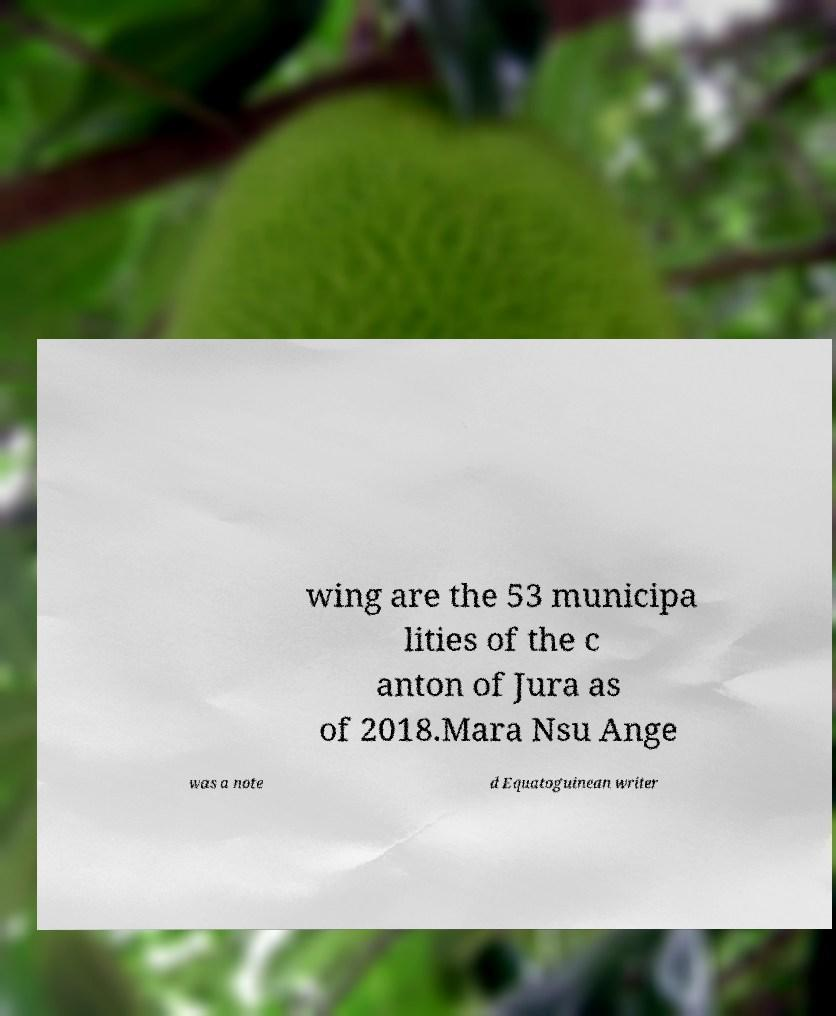I need the written content from this picture converted into text. Can you do that? wing are the 53 municipa lities of the c anton of Jura as of 2018.Mara Nsu Ange was a note d Equatoguinean writer 